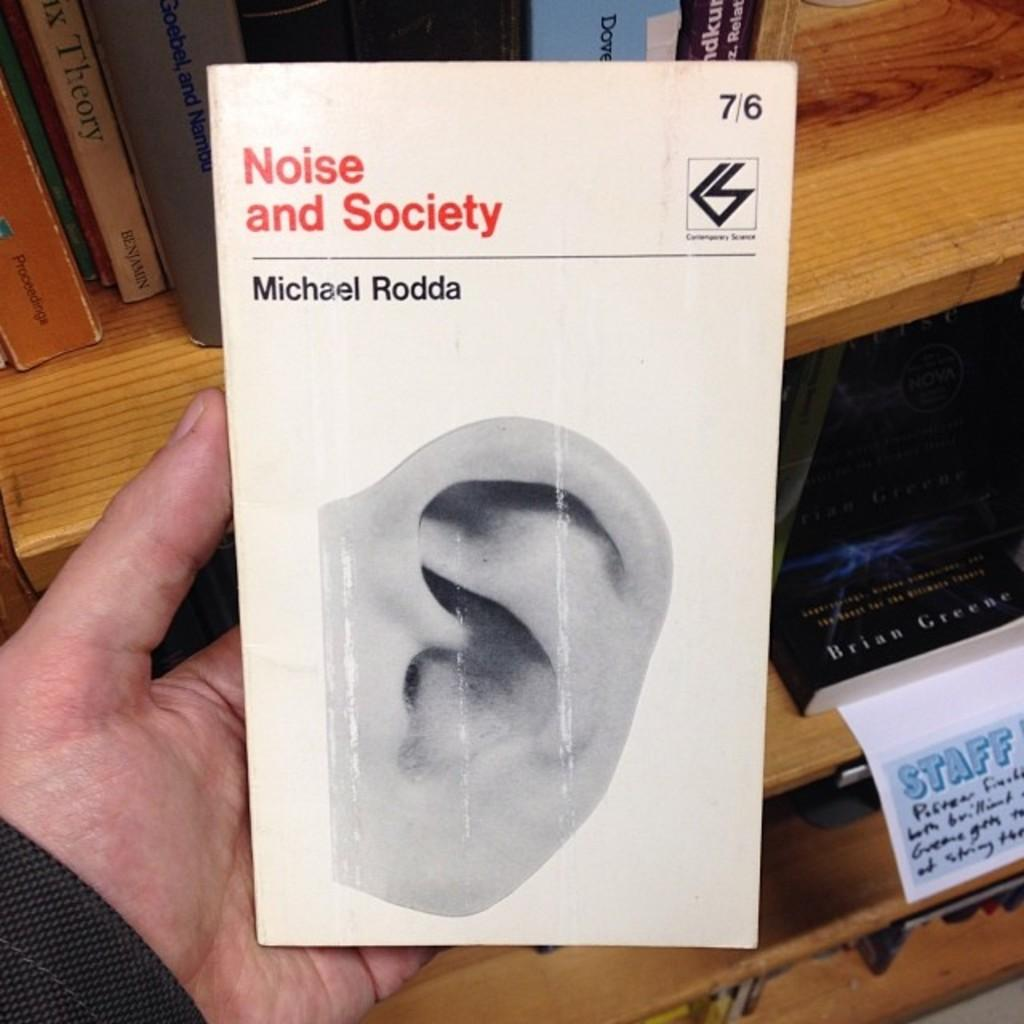Provide a one-sentence caption for the provided image. A book with an ear on the cover titled "Noise and Society". 